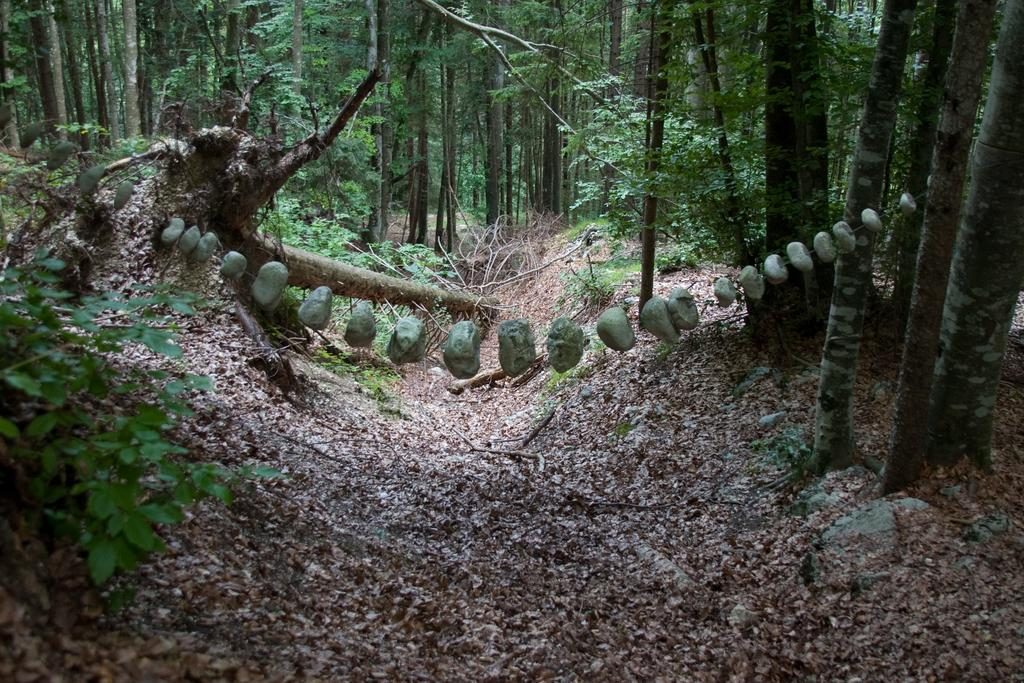What type of objects can be seen in the image that resemble stones? There are objects in the image that resemble stones. What can be seen in the background of the image? There are trees visible in the background of the image. What is the color of the trees in the image? The trees are green in color. What type of produce is being advertised in the image? A: There is no produce being advertised in the image; it features objects that resemble stones and trees in the background. 